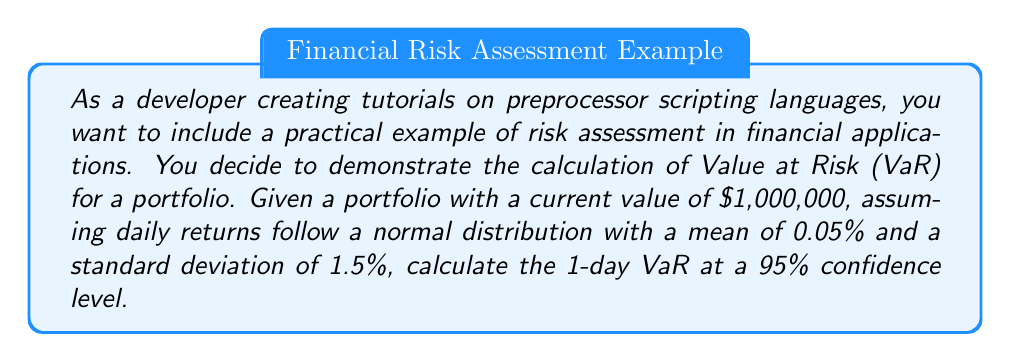What is the answer to this math problem? To calculate the Value at Risk (VaR) for the given portfolio, we'll follow these steps:

1. Identify the given information:
   - Portfolio value: $1,000,000
   - Confidence level: 95%
   - Time horizon: 1 day
   - Daily returns follow a normal distribution
   - Mean daily return (μ): 0.05%
   - Standard deviation of daily returns (σ): 1.5%

2. Find the z-score for the 95% confidence level:
   The z-score for a 95% confidence level is -1.645 (left tail).

3. Calculate the VaR using the formula:
   $$VaR = -(\mu + z \cdot \sigma) \cdot PortfolioValue$$

   Where:
   $\mu$ is the mean daily return
   $z$ is the z-score for the confidence level
   $\sigma$ is the standard deviation of daily returns

4. Plug in the values:
   $$VaR = -(0.0005 + (-1.645 \cdot 0.015)) \cdot 1,000,000$$

5. Simplify:
   $$VaR = -(0.0005 - 0.024675) \cdot 1,000,000$$
   $$VaR = -(-0.024175) \cdot 1,000,000$$
   $$VaR = 24,175$$

The VaR represents the potential loss, so we express it as a positive number.
Answer: The 1-day Value at Risk (VaR) at a 95% confidence level for the given portfolio is $24,175. 